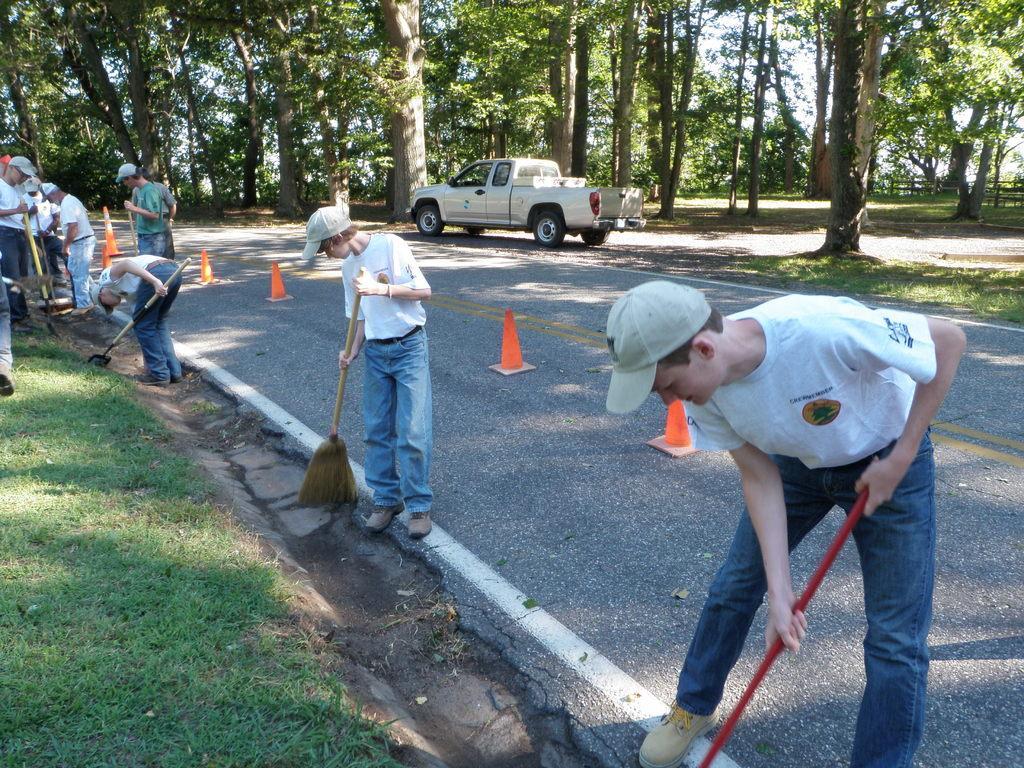Describe this image in one or two sentences. In this image we can see some group of persons wearing similar dress sweeping the road with the help of brooms there are some traffic cones on the road and at the background of the image there is vehicle and some trees. 